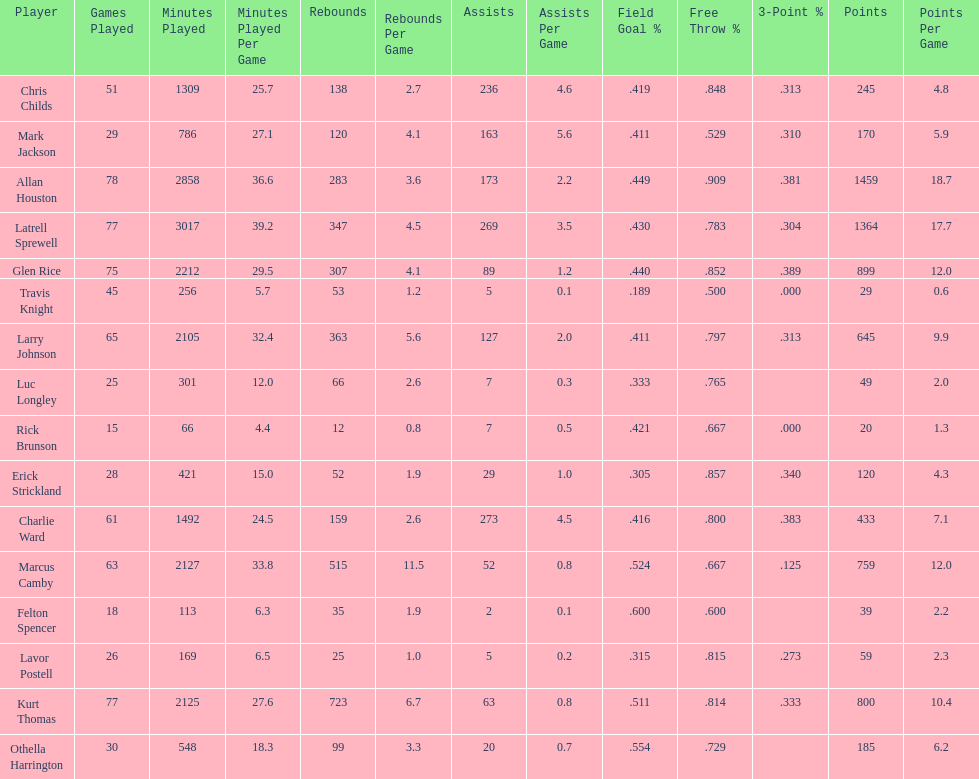How many total points were scored by players averaging over 4 assists per game> 848. Give me the full table as a dictionary. {'header': ['Player', 'Games Played', 'Minutes Played', 'Minutes Played Per Game', 'Rebounds', 'Rebounds Per Game', 'Assists', 'Assists Per Game', 'Field Goal\xa0%', 'Free Throw\xa0%', '3-Point\xa0%', 'Points', 'Points Per Game'], 'rows': [['Chris Childs', '51', '1309', '25.7', '138', '2.7', '236', '4.6', '.419', '.848', '.313', '245', '4.8'], ['Mark Jackson', '29', '786', '27.1', '120', '4.1', '163', '5.6', '.411', '.529', '.310', '170', '5.9'], ['Allan Houston', '78', '2858', '36.6', '283', '3.6', '173', '2.2', '.449', '.909', '.381', '1459', '18.7'], ['Latrell Sprewell', '77', '3017', '39.2', '347', '4.5', '269', '3.5', '.430', '.783', '.304', '1364', '17.7'], ['Glen Rice', '75', '2212', '29.5', '307', '4.1', '89', '1.2', '.440', '.852', '.389', '899', '12.0'], ['Travis Knight', '45', '256', '5.7', '53', '1.2', '5', '0.1', '.189', '.500', '.000', '29', '0.6'], ['Larry Johnson', '65', '2105', '32.4', '363', '5.6', '127', '2.0', '.411', '.797', '.313', '645', '9.9'], ['Luc Longley', '25', '301', '12.0', '66', '2.6', '7', '0.3', '.333', '.765', '', '49', '2.0'], ['Rick Brunson', '15', '66', '4.4', '12', '0.8', '7', '0.5', '.421', '.667', '.000', '20', '1.3'], ['Erick Strickland', '28', '421', '15.0', '52', '1.9', '29', '1.0', '.305', '.857', '.340', '120', '4.3'], ['Charlie Ward', '61', '1492', '24.5', '159', '2.6', '273', '4.5', '.416', '.800', '.383', '433', '7.1'], ['Marcus Camby', '63', '2127', '33.8', '515', '11.5', '52', '0.8', '.524', '.667', '.125', '759', '12.0'], ['Felton Spencer', '18', '113', '6.3', '35', '1.9', '2', '0.1', '.600', '.600', '', '39', '2.2'], ['Lavor Postell', '26', '169', '6.5', '25', '1.0', '5', '0.2', '.315', '.815', '.273', '59', '2.3'], ['Kurt Thomas', '77', '2125', '27.6', '723', '6.7', '63', '0.8', '.511', '.814', '.333', '800', '10.4'], ['Othella Harrington', '30', '548', '18.3', '99', '3.3', '20', '0.7', '.554', '.729', '', '185', '6.2']]} 